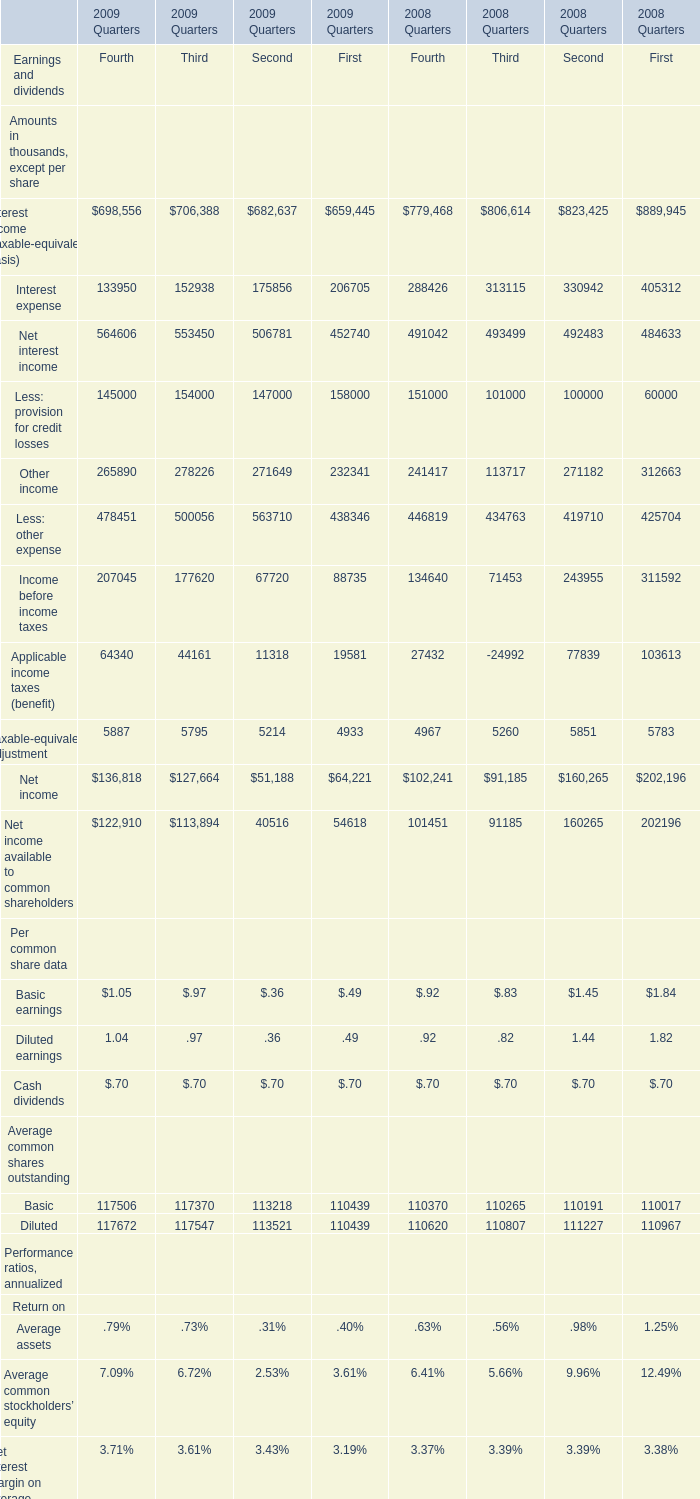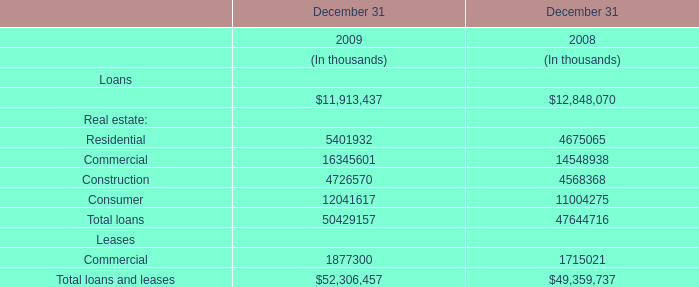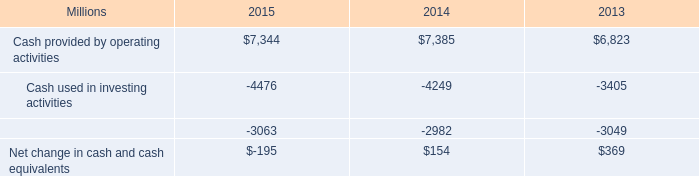What was the average value of Applicable income taxes (benefit), Taxable-equivalent adjustment, Net income for Fourth in 2009? (in thousand) 
Computations: (((64340 + 5887) + 136818) / 3)
Answer: 69015.0. 